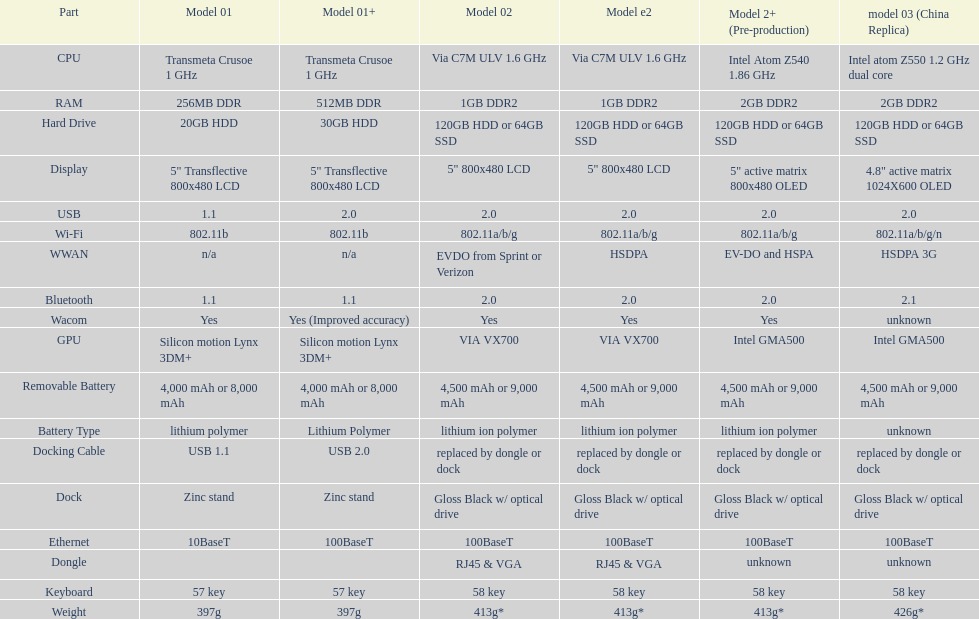Which model weighs the most, according to the table? Model 03 (china copy). 